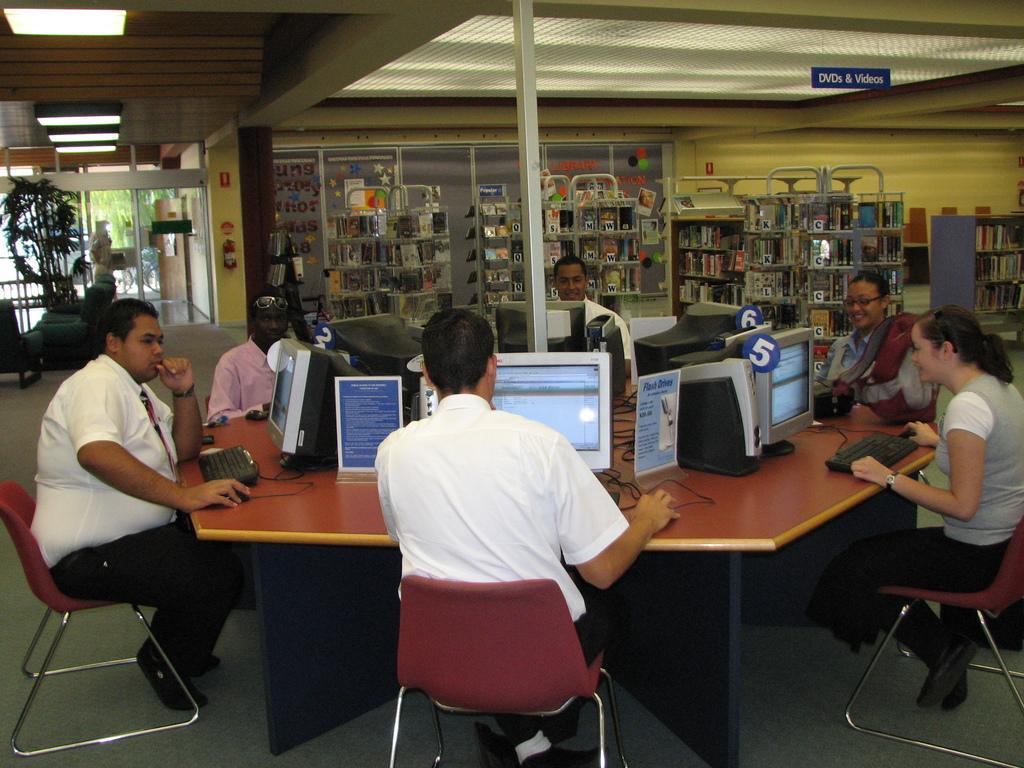Describe this image in one or two sentences. In this picture there are group of people sitting in the chair near the table and in table there are computers , name boards and in back ground there are some objects in the racks, a plant , door, light. 